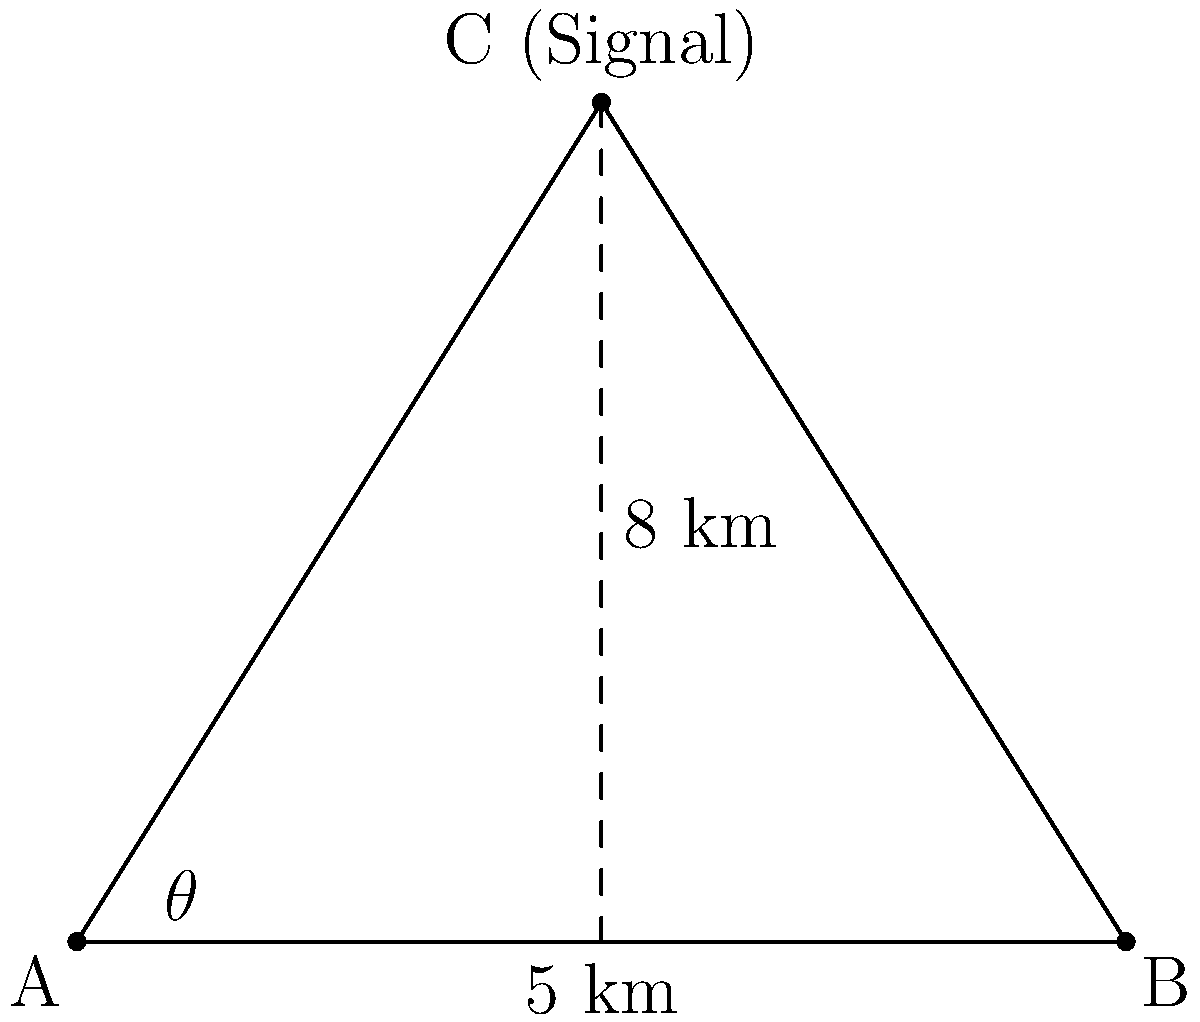In a search and rescue operation, two monitoring stations (A and B) are set up 10 km apart. They detect a radio signal from a distressed hiker (point C). Station A measures an angle of 58° between the line connecting the stations and the direction of the signal. The perpendicular distance from the line AB to the hiker's location is 8 km. Calculate the distance from station A to the hiker's location. Let's approach this step-by-step:

1) We have a right triangle formed by the perpendicular line from C to AB and half of AB.

2) Let's call the distance from A to the foot of the perpendicular x.

3) We know that:
   - The total distance AB is 10 km
   - The height of the triangle (perpendicular distance) is 8 km
   - The angle at A is 58°

4) In the right triangle, we can use the tangent function:

   $$\tan 58° = \frac{8}{x}$$

5) Solving for x:

   $$x = \frac{8}{\tan 58°}$$

6) Using a calculator (or trigonometric tables):

   $$x \approx 5.18 \text{ km}$$

7) Now we have a right triangle with base 5.18 km and height 8 km. We can use the Pythagorean theorem to find the hypotenuse, which is the distance from A to C:

   $$AC^2 = 5.18^2 + 8^2$$

8) Solving:

   $$AC = \sqrt{5.18^2 + 8^2} \approx 9.54 \text{ km}$$

Therefore, the distance from station A to the hiker's location is approximately 9.54 km.
Answer: 9.54 km 